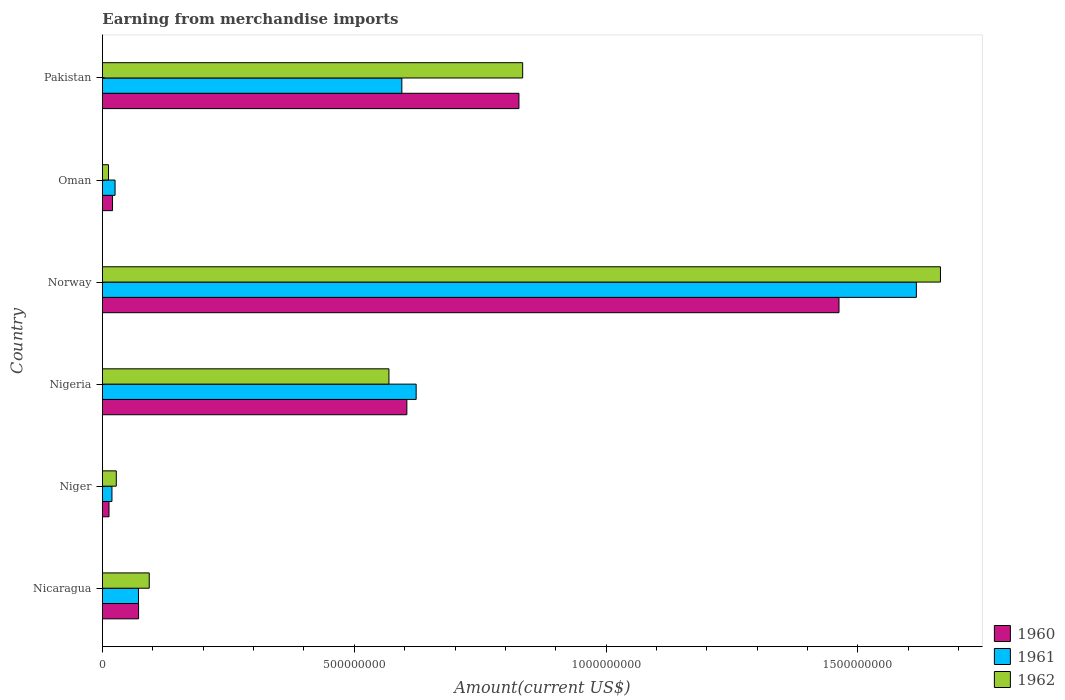How many groups of bars are there?
Provide a succinct answer. 6. Are the number of bars per tick equal to the number of legend labels?
Your response must be concise. Yes. Are the number of bars on each tick of the Y-axis equal?
Ensure brevity in your answer.  Yes. How many bars are there on the 1st tick from the bottom?
Your response must be concise. 3. What is the label of the 6th group of bars from the top?
Give a very brief answer. Nicaragua. What is the amount earned from merchandise imports in 1960 in Norway?
Make the answer very short. 1.46e+09. Across all countries, what is the maximum amount earned from merchandise imports in 1962?
Give a very brief answer. 1.66e+09. Across all countries, what is the minimum amount earned from merchandise imports in 1961?
Ensure brevity in your answer.  1.88e+07. In which country was the amount earned from merchandise imports in 1961 maximum?
Your answer should be very brief. Norway. In which country was the amount earned from merchandise imports in 1961 minimum?
Your answer should be compact. Niger. What is the total amount earned from merchandise imports in 1961 in the graph?
Ensure brevity in your answer.  2.95e+09. What is the difference between the amount earned from merchandise imports in 1960 in Nigeria and that in Oman?
Your answer should be compact. 5.84e+08. What is the difference between the amount earned from merchandise imports in 1962 in Niger and the amount earned from merchandise imports in 1960 in Oman?
Ensure brevity in your answer.  7.46e+06. What is the average amount earned from merchandise imports in 1962 per country?
Offer a terse response. 5.33e+08. What is the difference between the amount earned from merchandise imports in 1962 and amount earned from merchandise imports in 1960 in Oman?
Provide a succinct answer. -8.00e+06. What is the ratio of the amount earned from merchandise imports in 1960 in Nigeria to that in Oman?
Keep it short and to the point. 30.22. What is the difference between the highest and the second highest amount earned from merchandise imports in 1962?
Keep it short and to the point. 8.30e+08. What is the difference between the highest and the lowest amount earned from merchandise imports in 1960?
Your answer should be compact. 1.45e+09. Is the sum of the amount earned from merchandise imports in 1960 in Norway and Oman greater than the maximum amount earned from merchandise imports in 1961 across all countries?
Your answer should be very brief. No. Is it the case that in every country, the sum of the amount earned from merchandise imports in 1961 and amount earned from merchandise imports in 1960 is greater than the amount earned from merchandise imports in 1962?
Offer a very short reply. Yes. How many bars are there?
Make the answer very short. 18. Are all the bars in the graph horizontal?
Your response must be concise. Yes. What is the difference between two consecutive major ticks on the X-axis?
Ensure brevity in your answer.  5.00e+08. Does the graph contain grids?
Make the answer very short. No. How are the legend labels stacked?
Your response must be concise. Vertical. What is the title of the graph?
Your answer should be compact. Earning from merchandise imports. Does "2003" appear as one of the legend labels in the graph?
Your answer should be compact. No. What is the label or title of the X-axis?
Keep it short and to the point. Amount(current US$). What is the label or title of the Y-axis?
Make the answer very short. Country. What is the Amount(current US$) of 1960 in Nicaragua?
Ensure brevity in your answer.  7.17e+07. What is the Amount(current US$) of 1961 in Nicaragua?
Your answer should be compact. 7.15e+07. What is the Amount(current US$) in 1962 in Nicaragua?
Ensure brevity in your answer.  9.29e+07. What is the Amount(current US$) in 1960 in Niger?
Your answer should be compact. 1.30e+07. What is the Amount(current US$) in 1961 in Niger?
Your answer should be compact. 1.88e+07. What is the Amount(current US$) in 1962 in Niger?
Keep it short and to the point. 2.75e+07. What is the Amount(current US$) in 1960 in Nigeria?
Your answer should be compact. 6.04e+08. What is the Amount(current US$) in 1961 in Nigeria?
Give a very brief answer. 6.23e+08. What is the Amount(current US$) in 1962 in Nigeria?
Provide a succinct answer. 5.69e+08. What is the Amount(current US$) in 1960 in Norway?
Your answer should be compact. 1.46e+09. What is the Amount(current US$) in 1961 in Norway?
Your answer should be very brief. 1.62e+09. What is the Amount(current US$) in 1962 in Norway?
Keep it short and to the point. 1.66e+09. What is the Amount(current US$) in 1960 in Oman?
Provide a succinct answer. 2.00e+07. What is the Amount(current US$) of 1961 in Oman?
Provide a short and direct response. 2.50e+07. What is the Amount(current US$) in 1962 in Oman?
Provide a succinct answer. 1.20e+07. What is the Amount(current US$) of 1960 in Pakistan?
Offer a very short reply. 8.27e+08. What is the Amount(current US$) of 1961 in Pakistan?
Ensure brevity in your answer.  5.94e+08. What is the Amount(current US$) in 1962 in Pakistan?
Your answer should be very brief. 8.34e+08. Across all countries, what is the maximum Amount(current US$) in 1960?
Your response must be concise. 1.46e+09. Across all countries, what is the maximum Amount(current US$) in 1961?
Your answer should be very brief. 1.62e+09. Across all countries, what is the maximum Amount(current US$) in 1962?
Give a very brief answer. 1.66e+09. Across all countries, what is the minimum Amount(current US$) of 1960?
Offer a terse response. 1.30e+07. Across all countries, what is the minimum Amount(current US$) in 1961?
Keep it short and to the point. 1.88e+07. Across all countries, what is the minimum Amount(current US$) of 1962?
Offer a terse response. 1.20e+07. What is the total Amount(current US$) in 1960 in the graph?
Offer a terse response. 3.00e+09. What is the total Amount(current US$) of 1961 in the graph?
Ensure brevity in your answer.  2.95e+09. What is the total Amount(current US$) of 1962 in the graph?
Provide a succinct answer. 3.20e+09. What is the difference between the Amount(current US$) in 1960 in Nicaragua and that in Niger?
Provide a succinct answer. 5.87e+07. What is the difference between the Amount(current US$) in 1961 in Nicaragua and that in Niger?
Make the answer very short. 5.26e+07. What is the difference between the Amount(current US$) in 1962 in Nicaragua and that in Niger?
Give a very brief answer. 6.54e+07. What is the difference between the Amount(current US$) in 1960 in Nicaragua and that in Nigeria?
Offer a terse response. -5.33e+08. What is the difference between the Amount(current US$) of 1961 in Nicaragua and that in Nigeria?
Ensure brevity in your answer.  -5.51e+08. What is the difference between the Amount(current US$) in 1962 in Nicaragua and that in Nigeria?
Provide a short and direct response. -4.76e+08. What is the difference between the Amount(current US$) of 1960 in Nicaragua and that in Norway?
Provide a succinct answer. -1.39e+09. What is the difference between the Amount(current US$) of 1961 in Nicaragua and that in Norway?
Your response must be concise. -1.54e+09. What is the difference between the Amount(current US$) in 1962 in Nicaragua and that in Norway?
Give a very brief answer. -1.57e+09. What is the difference between the Amount(current US$) of 1960 in Nicaragua and that in Oman?
Give a very brief answer. 5.17e+07. What is the difference between the Amount(current US$) of 1961 in Nicaragua and that in Oman?
Your response must be concise. 4.65e+07. What is the difference between the Amount(current US$) of 1962 in Nicaragua and that in Oman?
Offer a terse response. 8.09e+07. What is the difference between the Amount(current US$) of 1960 in Nicaragua and that in Pakistan?
Offer a terse response. -7.55e+08. What is the difference between the Amount(current US$) in 1961 in Nicaragua and that in Pakistan?
Offer a terse response. -5.23e+08. What is the difference between the Amount(current US$) in 1962 in Nicaragua and that in Pakistan?
Offer a terse response. -7.41e+08. What is the difference between the Amount(current US$) in 1960 in Niger and that in Nigeria?
Your answer should be very brief. -5.91e+08. What is the difference between the Amount(current US$) of 1961 in Niger and that in Nigeria?
Offer a very short reply. -6.04e+08. What is the difference between the Amount(current US$) of 1962 in Niger and that in Nigeria?
Keep it short and to the point. -5.41e+08. What is the difference between the Amount(current US$) in 1960 in Niger and that in Norway?
Your answer should be very brief. -1.45e+09. What is the difference between the Amount(current US$) in 1961 in Niger and that in Norway?
Your answer should be compact. -1.60e+09. What is the difference between the Amount(current US$) of 1962 in Niger and that in Norway?
Offer a terse response. -1.64e+09. What is the difference between the Amount(current US$) in 1960 in Niger and that in Oman?
Provide a succinct answer. -7.01e+06. What is the difference between the Amount(current US$) of 1961 in Niger and that in Oman?
Your response must be concise. -6.15e+06. What is the difference between the Amount(current US$) of 1962 in Niger and that in Oman?
Your answer should be very brief. 1.55e+07. What is the difference between the Amount(current US$) of 1960 in Niger and that in Pakistan?
Your answer should be compact. -8.14e+08. What is the difference between the Amount(current US$) of 1961 in Niger and that in Pakistan?
Give a very brief answer. -5.76e+08. What is the difference between the Amount(current US$) of 1962 in Niger and that in Pakistan?
Your answer should be very brief. -8.07e+08. What is the difference between the Amount(current US$) in 1960 in Nigeria and that in Norway?
Keep it short and to the point. -8.58e+08. What is the difference between the Amount(current US$) in 1961 in Nigeria and that in Norway?
Make the answer very short. -9.93e+08. What is the difference between the Amount(current US$) of 1962 in Nigeria and that in Norway?
Keep it short and to the point. -1.10e+09. What is the difference between the Amount(current US$) in 1960 in Nigeria and that in Oman?
Offer a terse response. 5.84e+08. What is the difference between the Amount(current US$) in 1961 in Nigeria and that in Oman?
Ensure brevity in your answer.  5.98e+08. What is the difference between the Amount(current US$) in 1962 in Nigeria and that in Oman?
Offer a terse response. 5.57e+08. What is the difference between the Amount(current US$) in 1960 in Nigeria and that in Pakistan?
Make the answer very short. -2.23e+08. What is the difference between the Amount(current US$) of 1961 in Nigeria and that in Pakistan?
Keep it short and to the point. 2.84e+07. What is the difference between the Amount(current US$) in 1962 in Nigeria and that in Pakistan?
Your answer should be very brief. -2.66e+08. What is the difference between the Amount(current US$) of 1960 in Norway and that in Oman?
Provide a short and direct response. 1.44e+09. What is the difference between the Amount(current US$) in 1961 in Norway and that in Oman?
Offer a terse response. 1.59e+09. What is the difference between the Amount(current US$) in 1962 in Norway and that in Oman?
Give a very brief answer. 1.65e+09. What is the difference between the Amount(current US$) in 1960 in Norway and that in Pakistan?
Ensure brevity in your answer.  6.36e+08. What is the difference between the Amount(current US$) of 1961 in Norway and that in Pakistan?
Offer a terse response. 1.02e+09. What is the difference between the Amount(current US$) of 1962 in Norway and that in Pakistan?
Your answer should be compact. 8.30e+08. What is the difference between the Amount(current US$) in 1960 in Oman and that in Pakistan?
Your response must be concise. -8.07e+08. What is the difference between the Amount(current US$) in 1961 in Oman and that in Pakistan?
Offer a terse response. -5.69e+08. What is the difference between the Amount(current US$) of 1962 in Oman and that in Pakistan?
Provide a succinct answer. -8.22e+08. What is the difference between the Amount(current US$) of 1960 in Nicaragua and the Amount(current US$) of 1961 in Niger?
Your answer should be compact. 5.29e+07. What is the difference between the Amount(current US$) of 1960 in Nicaragua and the Amount(current US$) of 1962 in Niger?
Your response must be concise. 4.42e+07. What is the difference between the Amount(current US$) in 1961 in Nicaragua and the Amount(current US$) in 1962 in Niger?
Offer a very short reply. 4.40e+07. What is the difference between the Amount(current US$) of 1960 in Nicaragua and the Amount(current US$) of 1961 in Nigeria?
Your answer should be compact. -5.51e+08. What is the difference between the Amount(current US$) of 1960 in Nicaragua and the Amount(current US$) of 1962 in Nigeria?
Offer a terse response. -4.97e+08. What is the difference between the Amount(current US$) in 1961 in Nicaragua and the Amount(current US$) in 1962 in Nigeria?
Offer a very short reply. -4.97e+08. What is the difference between the Amount(current US$) of 1960 in Nicaragua and the Amount(current US$) of 1961 in Norway?
Your answer should be very brief. -1.54e+09. What is the difference between the Amount(current US$) in 1960 in Nicaragua and the Amount(current US$) in 1962 in Norway?
Give a very brief answer. -1.59e+09. What is the difference between the Amount(current US$) in 1961 in Nicaragua and the Amount(current US$) in 1962 in Norway?
Provide a short and direct response. -1.59e+09. What is the difference between the Amount(current US$) in 1960 in Nicaragua and the Amount(current US$) in 1961 in Oman?
Ensure brevity in your answer.  4.67e+07. What is the difference between the Amount(current US$) in 1960 in Nicaragua and the Amount(current US$) in 1962 in Oman?
Provide a short and direct response. 5.97e+07. What is the difference between the Amount(current US$) in 1961 in Nicaragua and the Amount(current US$) in 1962 in Oman?
Provide a succinct answer. 5.95e+07. What is the difference between the Amount(current US$) in 1960 in Nicaragua and the Amount(current US$) in 1961 in Pakistan?
Provide a succinct answer. -5.23e+08. What is the difference between the Amount(current US$) in 1960 in Nicaragua and the Amount(current US$) in 1962 in Pakistan?
Your answer should be compact. -7.63e+08. What is the difference between the Amount(current US$) of 1961 in Nicaragua and the Amount(current US$) of 1962 in Pakistan?
Offer a very short reply. -7.63e+08. What is the difference between the Amount(current US$) of 1960 in Niger and the Amount(current US$) of 1961 in Nigeria?
Keep it short and to the point. -6.10e+08. What is the difference between the Amount(current US$) of 1960 in Niger and the Amount(current US$) of 1962 in Nigeria?
Offer a terse response. -5.56e+08. What is the difference between the Amount(current US$) in 1961 in Niger and the Amount(current US$) in 1962 in Nigeria?
Keep it short and to the point. -5.50e+08. What is the difference between the Amount(current US$) of 1960 in Niger and the Amount(current US$) of 1961 in Norway?
Your answer should be very brief. -1.60e+09. What is the difference between the Amount(current US$) of 1960 in Niger and the Amount(current US$) of 1962 in Norway?
Offer a very short reply. -1.65e+09. What is the difference between the Amount(current US$) in 1961 in Niger and the Amount(current US$) in 1962 in Norway?
Your response must be concise. -1.65e+09. What is the difference between the Amount(current US$) of 1960 in Niger and the Amount(current US$) of 1961 in Oman?
Your answer should be compact. -1.20e+07. What is the difference between the Amount(current US$) in 1960 in Niger and the Amount(current US$) in 1962 in Oman?
Offer a terse response. 9.92e+05. What is the difference between the Amount(current US$) of 1961 in Niger and the Amount(current US$) of 1962 in Oman?
Your response must be concise. 6.85e+06. What is the difference between the Amount(current US$) in 1960 in Niger and the Amount(current US$) in 1961 in Pakistan?
Provide a succinct answer. -5.81e+08. What is the difference between the Amount(current US$) in 1960 in Niger and the Amount(current US$) in 1962 in Pakistan?
Offer a terse response. -8.21e+08. What is the difference between the Amount(current US$) in 1961 in Niger and the Amount(current US$) in 1962 in Pakistan?
Your response must be concise. -8.15e+08. What is the difference between the Amount(current US$) in 1960 in Nigeria and the Amount(current US$) in 1961 in Norway?
Your response must be concise. -1.01e+09. What is the difference between the Amount(current US$) of 1960 in Nigeria and the Amount(current US$) of 1962 in Norway?
Give a very brief answer. -1.06e+09. What is the difference between the Amount(current US$) of 1961 in Nigeria and the Amount(current US$) of 1962 in Norway?
Your answer should be very brief. -1.04e+09. What is the difference between the Amount(current US$) in 1960 in Nigeria and the Amount(current US$) in 1961 in Oman?
Provide a succinct answer. 5.79e+08. What is the difference between the Amount(current US$) in 1960 in Nigeria and the Amount(current US$) in 1962 in Oman?
Your answer should be compact. 5.92e+08. What is the difference between the Amount(current US$) in 1961 in Nigeria and the Amount(current US$) in 1962 in Oman?
Your answer should be very brief. 6.11e+08. What is the difference between the Amount(current US$) of 1960 in Nigeria and the Amount(current US$) of 1961 in Pakistan?
Offer a terse response. 9.96e+06. What is the difference between the Amount(current US$) of 1960 in Nigeria and the Amount(current US$) of 1962 in Pakistan?
Provide a succinct answer. -2.30e+08. What is the difference between the Amount(current US$) in 1961 in Nigeria and the Amount(current US$) in 1962 in Pakistan?
Offer a terse response. -2.11e+08. What is the difference between the Amount(current US$) of 1960 in Norway and the Amount(current US$) of 1961 in Oman?
Your answer should be compact. 1.44e+09. What is the difference between the Amount(current US$) of 1960 in Norway and the Amount(current US$) of 1962 in Oman?
Offer a terse response. 1.45e+09. What is the difference between the Amount(current US$) of 1961 in Norway and the Amount(current US$) of 1962 in Oman?
Your answer should be compact. 1.60e+09. What is the difference between the Amount(current US$) of 1960 in Norway and the Amount(current US$) of 1961 in Pakistan?
Provide a succinct answer. 8.68e+08. What is the difference between the Amount(current US$) in 1960 in Norway and the Amount(current US$) in 1962 in Pakistan?
Give a very brief answer. 6.28e+08. What is the difference between the Amount(current US$) of 1961 in Norway and the Amount(current US$) of 1962 in Pakistan?
Your answer should be very brief. 7.82e+08. What is the difference between the Amount(current US$) of 1960 in Oman and the Amount(current US$) of 1961 in Pakistan?
Your response must be concise. -5.74e+08. What is the difference between the Amount(current US$) of 1960 in Oman and the Amount(current US$) of 1962 in Pakistan?
Your answer should be very brief. -8.14e+08. What is the difference between the Amount(current US$) of 1961 in Oman and the Amount(current US$) of 1962 in Pakistan?
Ensure brevity in your answer.  -8.09e+08. What is the average Amount(current US$) of 1960 per country?
Provide a short and direct response. 5.00e+08. What is the average Amount(current US$) in 1961 per country?
Make the answer very short. 4.91e+08. What is the average Amount(current US$) of 1962 per country?
Your answer should be very brief. 5.33e+08. What is the difference between the Amount(current US$) in 1960 and Amount(current US$) in 1962 in Nicaragua?
Provide a succinct answer. -2.12e+07. What is the difference between the Amount(current US$) of 1961 and Amount(current US$) of 1962 in Nicaragua?
Your response must be concise. -2.14e+07. What is the difference between the Amount(current US$) of 1960 and Amount(current US$) of 1961 in Niger?
Offer a very short reply. -5.86e+06. What is the difference between the Amount(current US$) of 1960 and Amount(current US$) of 1962 in Niger?
Provide a succinct answer. -1.45e+07. What is the difference between the Amount(current US$) in 1961 and Amount(current US$) in 1962 in Niger?
Keep it short and to the point. -8.61e+06. What is the difference between the Amount(current US$) in 1960 and Amount(current US$) in 1961 in Nigeria?
Keep it short and to the point. -1.85e+07. What is the difference between the Amount(current US$) of 1960 and Amount(current US$) of 1962 in Nigeria?
Provide a succinct answer. 3.56e+07. What is the difference between the Amount(current US$) of 1961 and Amount(current US$) of 1962 in Nigeria?
Your answer should be compact. 5.40e+07. What is the difference between the Amount(current US$) of 1960 and Amount(current US$) of 1961 in Norway?
Make the answer very short. -1.54e+08. What is the difference between the Amount(current US$) in 1960 and Amount(current US$) in 1962 in Norway?
Provide a succinct answer. -2.01e+08. What is the difference between the Amount(current US$) in 1961 and Amount(current US$) in 1962 in Norway?
Keep it short and to the point. -4.79e+07. What is the difference between the Amount(current US$) in 1960 and Amount(current US$) in 1961 in Oman?
Your response must be concise. -5.00e+06. What is the difference between the Amount(current US$) in 1961 and Amount(current US$) in 1962 in Oman?
Give a very brief answer. 1.30e+07. What is the difference between the Amount(current US$) in 1960 and Amount(current US$) in 1961 in Pakistan?
Offer a very short reply. 2.33e+08. What is the difference between the Amount(current US$) in 1960 and Amount(current US$) in 1962 in Pakistan?
Keep it short and to the point. -7.41e+06. What is the difference between the Amount(current US$) of 1961 and Amount(current US$) of 1962 in Pakistan?
Give a very brief answer. -2.40e+08. What is the ratio of the Amount(current US$) of 1960 in Nicaragua to that in Niger?
Give a very brief answer. 5.52. What is the ratio of the Amount(current US$) in 1961 in Nicaragua to that in Niger?
Make the answer very short. 3.79. What is the ratio of the Amount(current US$) in 1962 in Nicaragua to that in Niger?
Offer a very short reply. 3.38. What is the ratio of the Amount(current US$) in 1960 in Nicaragua to that in Nigeria?
Offer a very short reply. 0.12. What is the ratio of the Amount(current US$) of 1961 in Nicaragua to that in Nigeria?
Your response must be concise. 0.11. What is the ratio of the Amount(current US$) in 1962 in Nicaragua to that in Nigeria?
Offer a very short reply. 0.16. What is the ratio of the Amount(current US$) of 1960 in Nicaragua to that in Norway?
Offer a very short reply. 0.05. What is the ratio of the Amount(current US$) of 1961 in Nicaragua to that in Norway?
Offer a very short reply. 0.04. What is the ratio of the Amount(current US$) in 1962 in Nicaragua to that in Norway?
Offer a very short reply. 0.06. What is the ratio of the Amount(current US$) of 1960 in Nicaragua to that in Oman?
Offer a very short reply. 3.59. What is the ratio of the Amount(current US$) in 1961 in Nicaragua to that in Oman?
Ensure brevity in your answer.  2.86. What is the ratio of the Amount(current US$) of 1962 in Nicaragua to that in Oman?
Keep it short and to the point. 7.74. What is the ratio of the Amount(current US$) of 1960 in Nicaragua to that in Pakistan?
Ensure brevity in your answer.  0.09. What is the ratio of the Amount(current US$) in 1961 in Nicaragua to that in Pakistan?
Provide a succinct answer. 0.12. What is the ratio of the Amount(current US$) of 1962 in Nicaragua to that in Pakistan?
Provide a short and direct response. 0.11. What is the ratio of the Amount(current US$) of 1960 in Niger to that in Nigeria?
Your response must be concise. 0.02. What is the ratio of the Amount(current US$) of 1961 in Niger to that in Nigeria?
Your answer should be very brief. 0.03. What is the ratio of the Amount(current US$) in 1962 in Niger to that in Nigeria?
Keep it short and to the point. 0.05. What is the ratio of the Amount(current US$) in 1960 in Niger to that in Norway?
Provide a short and direct response. 0.01. What is the ratio of the Amount(current US$) of 1961 in Niger to that in Norway?
Offer a very short reply. 0.01. What is the ratio of the Amount(current US$) of 1962 in Niger to that in Norway?
Offer a very short reply. 0.02. What is the ratio of the Amount(current US$) of 1960 in Niger to that in Oman?
Your answer should be compact. 0.65. What is the ratio of the Amount(current US$) in 1961 in Niger to that in Oman?
Offer a terse response. 0.75. What is the ratio of the Amount(current US$) of 1962 in Niger to that in Oman?
Your answer should be very brief. 2.29. What is the ratio of the Amount(current US$) in 1960 in Niger to that in Pakistan?
Keep it short and to the point. 0.02. What is the ratio of the Amount(current US$) of 1961 in Niger to that in Pakistan?
Give a very brief answer. 0.03. What is the ratio of the Amount(current US$) in 1962 in Niger to that in Pakistan?
Provide a short and direct response. 0.03. What is the ratio of the Amount(current US$) of 1960 in Nigeria to that in Norway?
Provide a short and direct response. 0.41. What is the ratio of the Amount(current US$) in 1961 in Nigeria to that in Norway?
Offer a terse response. 0.39. What is the ratio of the Amount(current US$) of 1962 in Nigeria to that in Norway?
Your response must be concise. 0.34. What is the ratio of the Amount(current US$) in 1960 in Nigeria to that in Oman?
Provide a succinct answer. 30.22. What is the ratio of the Amount(current US$) of 1961 in Nigeria to that in Oman?
Your answer should be compact. 24.91. What is the ratio of the Amount(current US$) in 1962 in Nigeria to that in Oman?
Your answer should be very brief. 47.4. What is the ratio of the Amount(current US$) of 1960 in Nigeria to that in Pakistan?
Ensure brevity in your answer.  0.73. What is the ratio of the Amount(current US$) in 1961 in Nigeria to that in Pakistan?
Ensure brevity in your answer.  1.05. What is the ratio of the Amount(current US$) of 1962 in Nigeria to that in Pakistan?
Your response must be concise. 0.68. What is the ratio of the Amount(current US$) of 1960 in Norway to that in Oman?
Your answer should be compact. 73.12. What is the ratio of the Amount(current US$) of 1961 in Norway to that in Oman?
Make the answer very short. 64.64. What is the ratio of the Amount(current US$) in 1962 in Norway to that in Oman?
Give a very brief answer. 138.66. What is the ratio of the Amount(current US$) of 1960 in Norway to that in Pakistan?
Your answer should be compact. 1.77. What is the ratio of the Amount(current US$) of 1961 in Norway to that in Pakistan?
Offer a very short reply. 2.72. What is the ratio of the Amount(current US$) of 1962 in Norway to that in Pakistan?
Give a very brief answer. 1.99. What is the ratio of the Amount(current US$) in 1960 in Oman to that in Pakistan?
Give a very brief answer. 0.02. What is the ratio of the Amount(current US$) of 1961 in Oman to that in Pakistan?
Your answer should be very brief. 0.04. What is the ratio of the Amount(current US$) of 1962 in Oman to that in Pakistan?
Your answer should be compact. 0.01. What is the difference between the highest and the second highest Amount(current US$) in 1960?
Your response must be concise. 6.36e+08. What is the difference between the highest and the second highest Amount(current US$) of 1961?
Ensure brevity in your answer.  9.93e+08. What is the difference between the highest and the second highest Amount(current US$) of 1962?
Ensure brevity in your answer.  8.30e+08. What is the difference between the highest and the lowest Amount(current US$) of 1960?
Offer a terse response. 1.45e+09. What is the difference between the highest and the lowest Amount(current US$) of 1961?
Offer a terse response. 1.60e+09. What is the difference between the highest and the lowest Amount(current US$) of 1962?
Ensure brevity in your answer.  1.65e+09. 